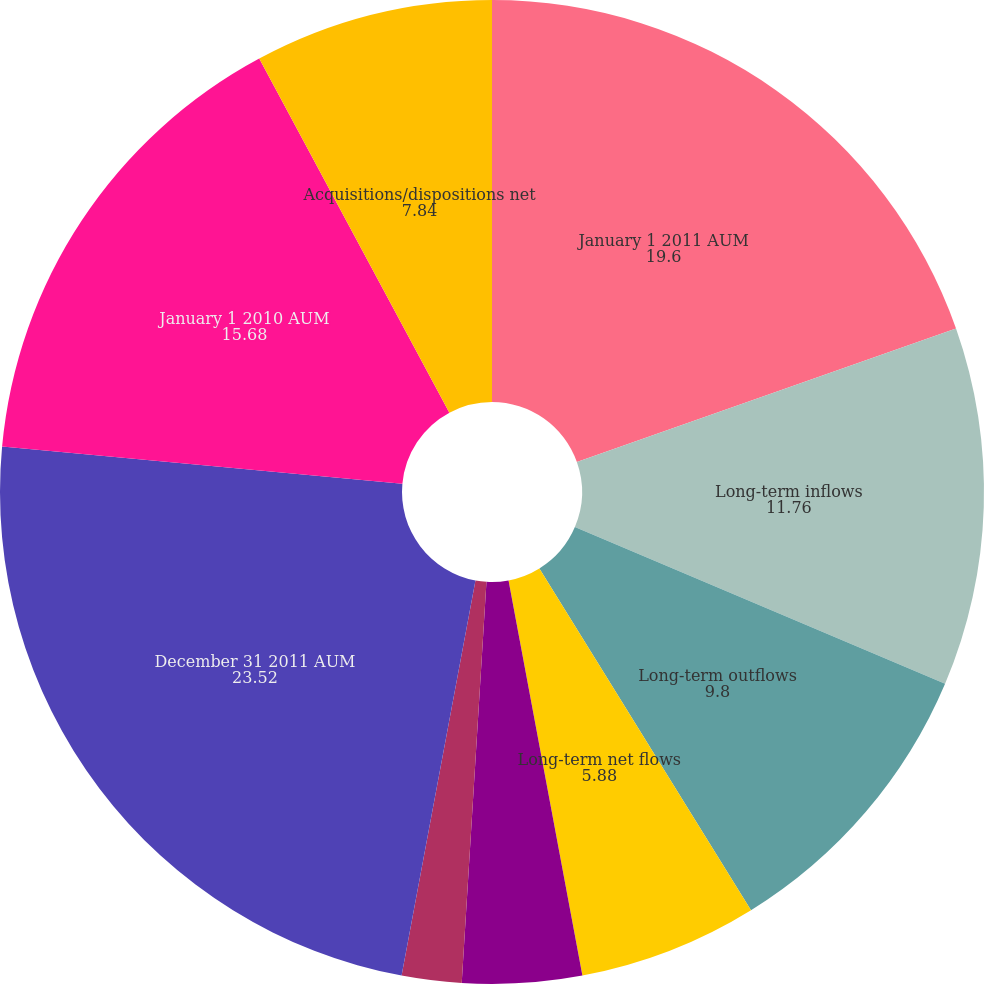Convert chart. <chart><loc_0><loc_0><loc_500><loc_500><pie_chart><fcel>January 1 2011 AUM<fcel>Long-term inflows<fcel>Long-term outflows<fcel>Long-term net flows<fcel>Net flows in institutional<fcel>Market gains and<fcel>December 31 2011 AUM<fcel>January 1 2010 AUM<fcel>Acquisitions/dispositions net<fcel>Foreign currency translation<nl><fcel>19.6%<fcel>11.76%<fcel>9.8%<fcel>5.88%<fcel>3.92%<fcel>1.96%<fcel>23.52%<fcel>15.68%<fcel>7.84%<fcel>0.0%<nl></chart> 